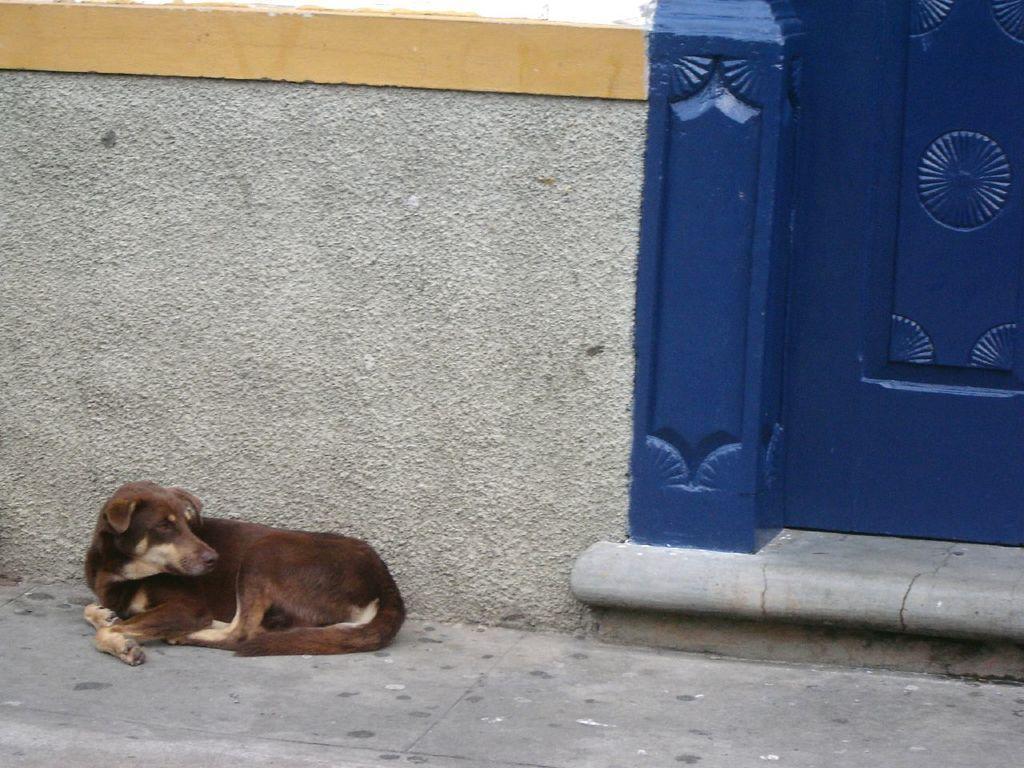In one or two sentences, can you explain what this image depicts? In the picture we can see a dog sitting near the wall and beside it, we can see a part of the door which is blue in color. 